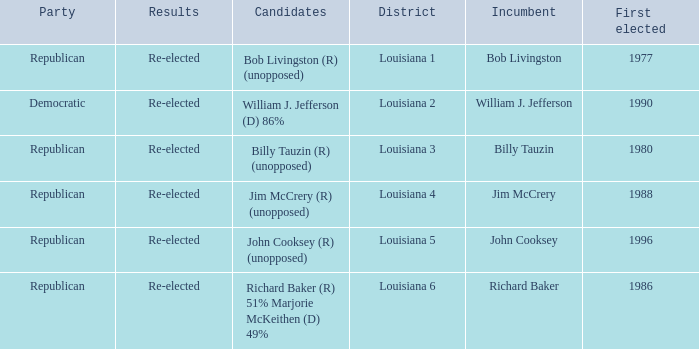What region does john cooksey represent? Louisiana 5. 